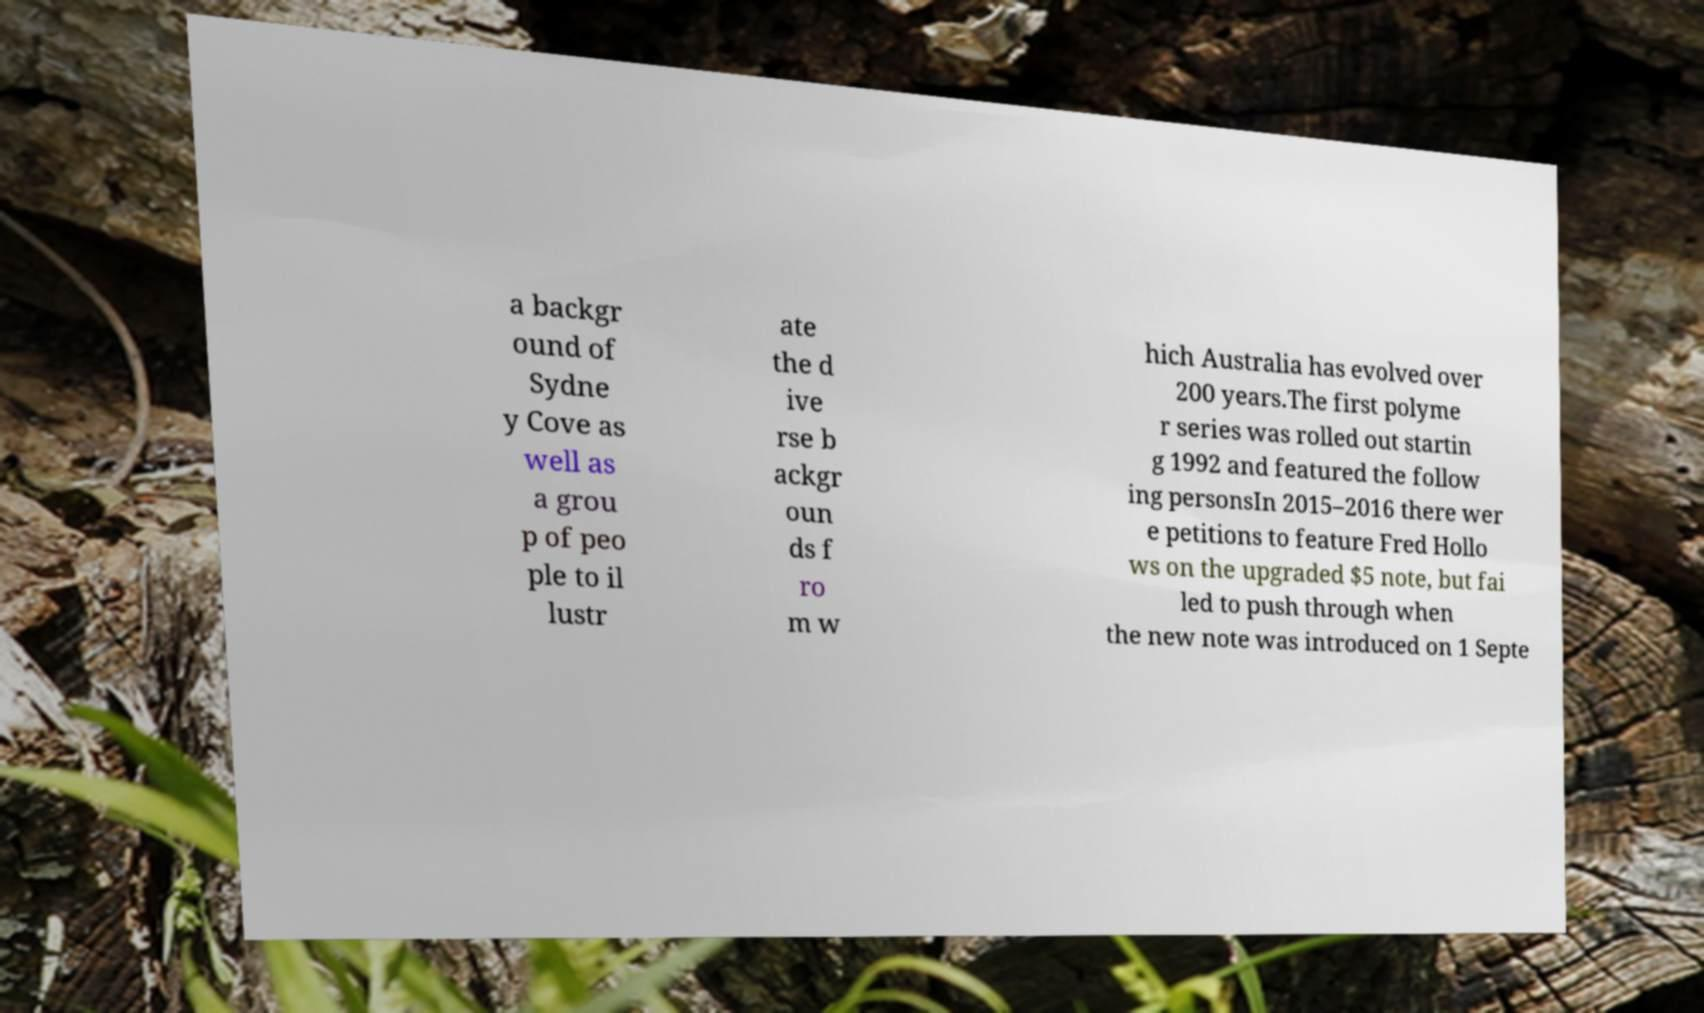Can you accurately transcribe the text from the provided image for me? a backgr ound of Sydne y Cove as well as a grou p of peo ple to il lustr ate the d ive rse b ackgr oun ds f ro m w hich Australia has evolved over 200 years.The first polyme r series was rolled out startin g 1992 and featured the follow ing personsIn 2015–2016 there wer e petitions to feature Fred Hollo ws on the upgraded $5 note, but fai led to push through when the new note was introduced on 1 Septe 